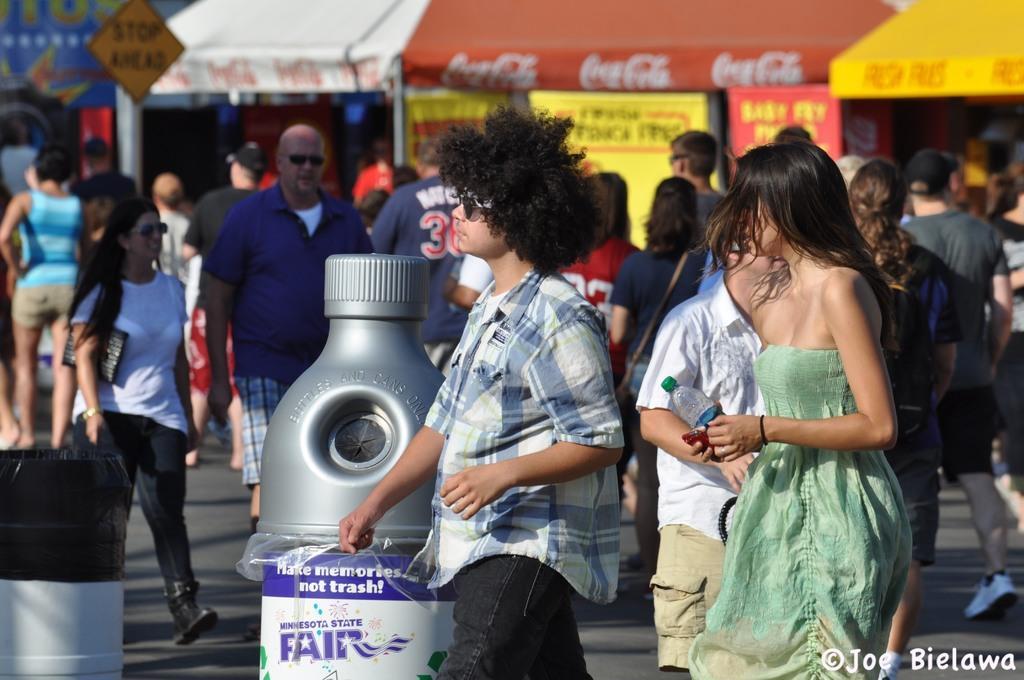Please provide a concise description of this image. There are many people walking in this picture. There is a big bottle placed on the road. There are men and women in this people. In the background there is a board and some tents here. 